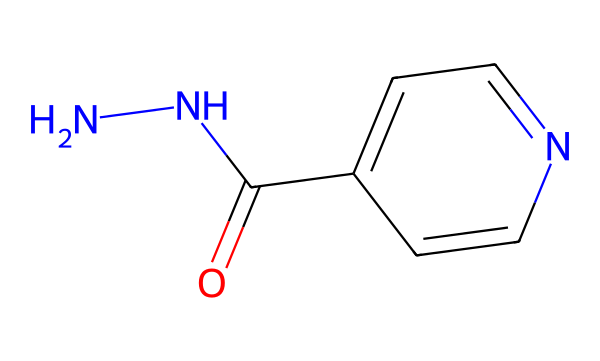What is the molecular formula for isoniazid based on its SMILES representation? The SMILES shows the atoms being represented: there are 6 carbons (c), 7 hydrogens (H), 2 nitrogens (N), and 1 oxygen (O). Therefore, the molecular formula can be constructed as C6H6N4O.
Answer: C6H6N4O How many nitrogen atoms are present in isoniazid? By analyzing the SMILES, we see there are two nitrogen atoms denoted by 'N' in the structure.
Answer: 2 What functional group is indicated by the 'C(=O)' in isoniazid? The 'C(=O)' indicates a carbon atom double bonded to an oxygen atom, which represents a carbonyl functional group. This is common in amides.
Answer: carbonyl What type of hybridization does the nitrogen in isoniazid exhibit? The nitrogen atoms in isoniazid are attached to multiple bonds, which typically indicates sp2 hybridization to accommodate the angles and bonds present in the structure.
Answer: sp2 What role do hydrazines play in the structure of isoniazid? The hydrazine part of isoniazid hinges on the nitrogen atoms, contributing to its biological activity by forming hydrazone bonds that interact with bacterial enzymes.
Answer: biological activity Which heteroatom in the chemical structure contributes to its function as an antibiotic? The presence of nitrogen at multiple sites contributes to its function; they participate in binding with enzyme targets in bacteria.
Answer: nitrogen What type of chemical reaction is likely involved in the mode of action of isoniazid? Isoniazid acts primarily through inhibition of the synthesis of mycolic acids in bacteria, which involves a reaction mechanism known as acylation, where it modifies target proteins.
Answer: acylation 